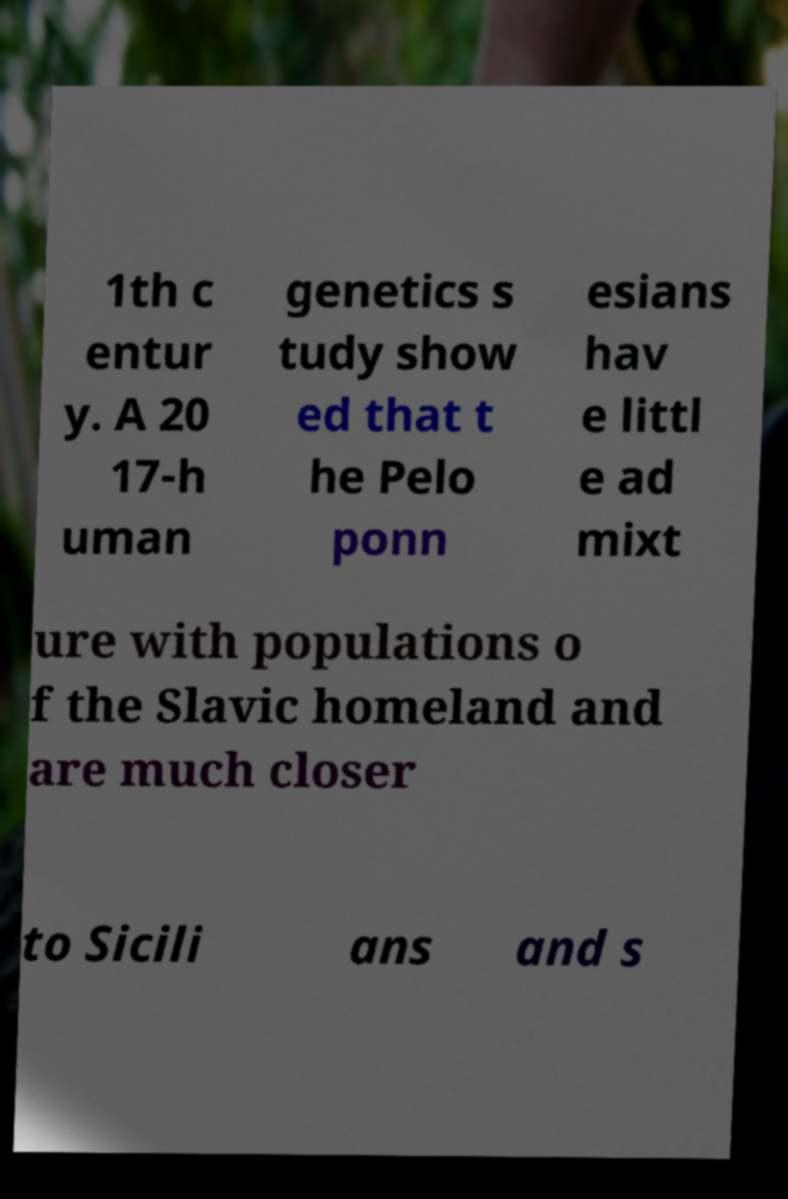There's text embedded in this image that I need extracted. Can you transcribe it verbatim? 1th c entur y. A 20 17-h uman genetics s tudy show ed that t he Pelo ponn esians hav e littl e ad mixt ure with populations o f the Slavic homeland and are much closer to Sicili ans and s 